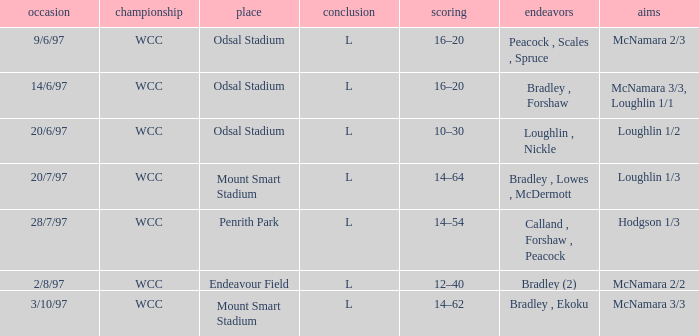Can you recall the efforts taken on 14th june 1997? Bradley , Forshaw. 